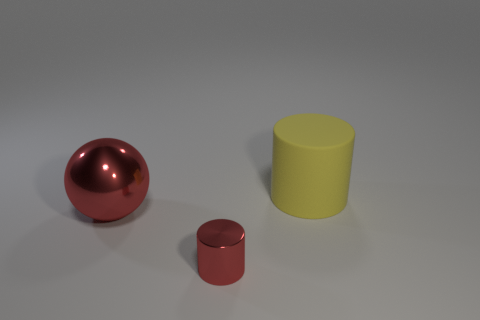The red object to the right of the big thing that is on the left side of the cylinder left of the big matte thing is made of what material? The red object in question appears glossy and has a smooth surface with reflective qualities, suggesting that it is made of a polished metal, possibly painted or anodized to achieve that vibrant red color. 